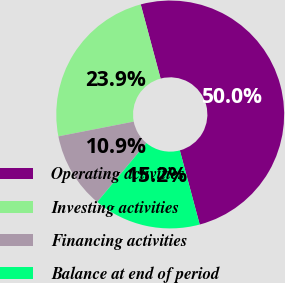Convert chart. <chart><loc_0><loc_0><loc_500><loc_500><pie_chart><fcel>Operating activities<fcel>Investing activities<fcel>Financing activities<fcel>Balance at end of period<nl><fcel>50.0%<fcel>23.91%<fcel>10.87%<fcel>15.22%<nl></chart> 